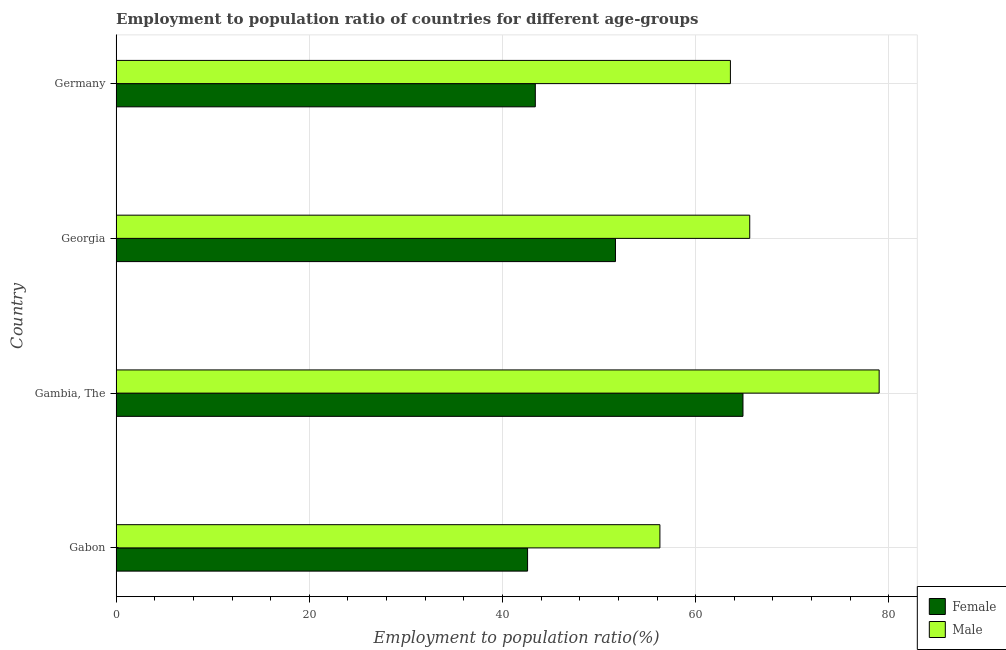Are the number of bars per tick equal to the number of legend labels?
Offer a very short reply. Yes. Are the number of bars on each tick of the Y-axis equal?
Make the answer very short. Yes. How many bars are there on the 4th tick from the bottom?
Ensure brevity in your answer.  2. What is the label of the 2nd group of bars from the top?
Provide a short and direct response. Georgia. In how many cases, is the number of bars for a given country not equal to the number of legend labels?
Make the answer very short. 0. What is the employment to population ratio(female) in Gambia, The?
Offer a very short reply. 64.9. Across all countries, what is the maximum employment to population ratio(female)?
Offer a terse response. 64.9. Across all countries, what is the minimum employment to population ratio(male)?
Offer a very short reply. 56.3. In which country was the employment to population ratio(female) maximum?
Offer a terse response. Gambia, The. In which country was the employment to population ratio(female) minimum?
Make the answer very short. Gabon. What is the total employment to population ratio(female) in the graph?
Provide a short and direct response. 202.6. What is the difference between the employment to population ratio(male) in Gabon and that in Gambia, The?
Give a very brief answer. -22.7. What is the difference between the employment to population ratio(male) in Georgia and the employment to population ratio(female) in Gabon?
Provide a short and direct response. 23. What is the average employment to population ratio(male) per country?
Make the answer very short. 66.12. What is the ratio of the employment to population ratio(female) in Gambia, The to that in Germany?
Make the answer very short. 1.5. Is the difference between the employment to population ratio(female) in Gambia, The and Germany greater than the difference between the employment to population ratio(male) in Gambia, The and Germany?
Make the answer very short. Yes. What is the difference between the highest and the second highest employment to population ratio(male)?
Ensure brevity in your answer.  13.4. What is the difference between the highest and the lowest employment to population ratio(male)?
Your response must be concise. 22.7. What does the 2nd bar from the top in Gabon represents?
Your response must be concise. Female. How many bars are there?
Offer a terse response. 8. Are all the bars in the graph horizontal?
Keep it short and to the point. Yes. How many countries are there in the graph?
Your response must be concise. 4. Are the values on the major ticks of X-axis written in scientific E-notation?
Provide a short and direct response. No. Does the graph contain any zero values?
Keep it short and to the point. No. Does the graph contain grids?
Provide a short and direct response. Yes. How many legend labels are there?
Your answer should be very brief. 2. What is the title of the graph?
Keep it short and to the point. Employment to population ratio of countries for different age-groups. What is the label or title of the X-axis?
Ensure brevity in your answer.  Employment to population ratio(%). What is the label or title of the Y-axis?
Make the answer very short. Country. What is the Employment to population ratio(%) of Female in Gabon?
Give a very brief answer. 42.6. What is the Employment to population ratio(%) of Male in Gabon?
Provide a succinct answer. 56.3. What is the Employment to population ratio(%) in Female in Gambia, The?
Provide a short and direct response. 64.9. What is the Employment to population ratio(%) in Male in Gambia, The?
Give a very brief answer. 79. What is the Employment to population ratio(%) of Female in Georgia?
Give a very brief answer. 51.7. What is the Employment to population ratio(%) of Male in Georgia?
Offer a terse response. 65.6. What is the Employment to population ratio(%) in Female in Germany?
Keep it short and to the point. 43.4. What is the Employment to population ratio(%) of Male in Germany?
Ensure brevity in your answer.  63.6. Across all countries, what is the maximum Employment to population ratio(%) in Female?
Offer a terse response. 64.9. Across all countries, what is the maximum Employment to population ratio(%) of Male?
Offer a terse response. 79. Across all countries, what is the minimum Employment to population ratio(%) in Female?
Offer a terse response. 42.6. Across all countries, what is the minimum Employment to population ratio(%) of Male?
Provide a short and direct response. 56.3. What is the total Employment to population ratio(%) of Female in the graph?
Your answer should be very brief. 202.6. What is the total Employment to population ratio(%) of Male in the graph?
Your answer should be compact. 264.5. What is the difference between the Employment to population ratio(%) in Female in Gabon and that in Gambia, The?
Make the answer very short. -22.3. What is the difference between the Employment to population ratio(%) in Male in Gabon and that in Gambia, The?
Provide a short and direct response. -22.7. What is the difference between the Employment to population ratio(%) of Female in Gabon and that in Germany?
Your response must be concise. -0.8. What is the difference between the Employment to population ratio(%) in Male in Gambia, The and that in Germany?
Give a very brief answer. 15.4. What is the difference between the Employment to population ratio(%) in Female in Georgia and that in Germany?
Provide a short and direct response. 8.3. What is the difference between the Employment to population ratio(%) in Female in Gabon and the Employment to population ratio(%) in Male in Gambia, The?
Offer a terse response. -36.4. What is the difference between the Employment to population ratio(%) of Female in Gabon and the Employment to population ratio(%) of Male in Georgia?
Offer a terse response. -23. What is the difference between the Employment to population ratio(%) of Female in Gabon and the Employment to population ratio(%) of Male in Germany?
Ensure brevity in your answer.  -21. What is the difference between the Employment to population ratio(%) in Female in Gambia, The and the Employment to population ratio(%) in Male in Georgia?
Offer a very short reply. -0.7. What is the difference between the Employment to population ratio(%) of Female in Gambia, The and the Employment to population ratio(%) of Male in Germany?
Ensure brevity in your answer.  1.3. What is the difference between the Employment to population ratio(%) in Female in Georgia and the Employment to population ratio(%) in Male in Germany?
Give a very brief answer. -11.9. What is the average Employment to population ratio(%) in Female per country?
Your answer should be compact. 50.65. What is the average Employment to population ratio(%) in Male per country?
Offer a very short reply. 66.12. What is the difference between the Employment to population ratio(%) of Female and Employment to population ratio(%) of Male in Gabon?
Offer a very short reply. -13.7. What is the difference between the Employment to population ratio(%) of Female and Employment to population ratio(%) of Male in Gambia, The?
Keep it short and to the point. -14.1. What is the difference between the Employment to population ratio(%) in Female and Employment to population ratio(%) in Male in Georgia?
Your answer should be compact. -13.9. What is the difference between the Employment to population ratio(%) of Female and Employment to population ratio(%) of Male in Germany?
Ensure brevity in your answer.  -20.2. What is the ratio of the Employment to population ratio(%) of Female in Gabon to that in Gambia, The?
Ensure brevity in your answer.  0.66. What is the ratio of the Employment to population ratio(%) in Male in Gabon to that in Gambia, The?
Ensure brevity in your answer.  0.71. What is the ratio of the Employment to population ratio(%) in Female in Gabon to that in Georgia?
Your response must be concise. 0.82. What is the ratio of the Employment to population ratio(%) of Male in Gabon to that in Georgia?
Provide a succinct answer. 0.86. What is the ratio of the Employment to population ratio(%) in Female in Gabon to that in Germany?
Ensure brevity in your answer.  0.98. What is the ratio of the Employment to population ratio(%) of Male in Gabon to that in Germany?
Your answer should be very brief. 0.89. What is the ratio of the Employment to population ratio(%) in Female in Gambia, The to that in Georgia?
Keep it short and to the point. 1.26. What is the ratio of the Employment to population ratio(%) of Male in Gambia, The to that in Georgia?
Ensure brevity in your answer.  1.2. What is the ratio of the Employment to population ratio(%) of Female in Gambia, The to that in Germany?
Offer a terse response. 1.5. What is the ratio of the Employment to population ratio(%) of Male in Gambia, The to that in Germany?
Your answer should be very brief. 1.24. What is the ratio of the Employment to population ratio(%) of Female in Georgia to that in Germany?
Make the answer very short. 1.19. What is the ratio of the Employment to population ratio(%) of Male in Georgia to that in Germany?
Offer a very short reply. 1.03. What is the difference between the highest and the second highest Employment to population ratio(%) of Female?
Your response must be concise. 13.2. What is the difference between the highest and the second highest Employment to population ratio(%) in Male?
Make the answer very short. 13.4. What is the difference between the highest and the lowest Employment to population ratio(%) in Female?
Offer a terse response. 22.3. What is the difference between the highest and the lowest Employment to population ratio(%) in Male?
Offer a very short reply. 22.7. 